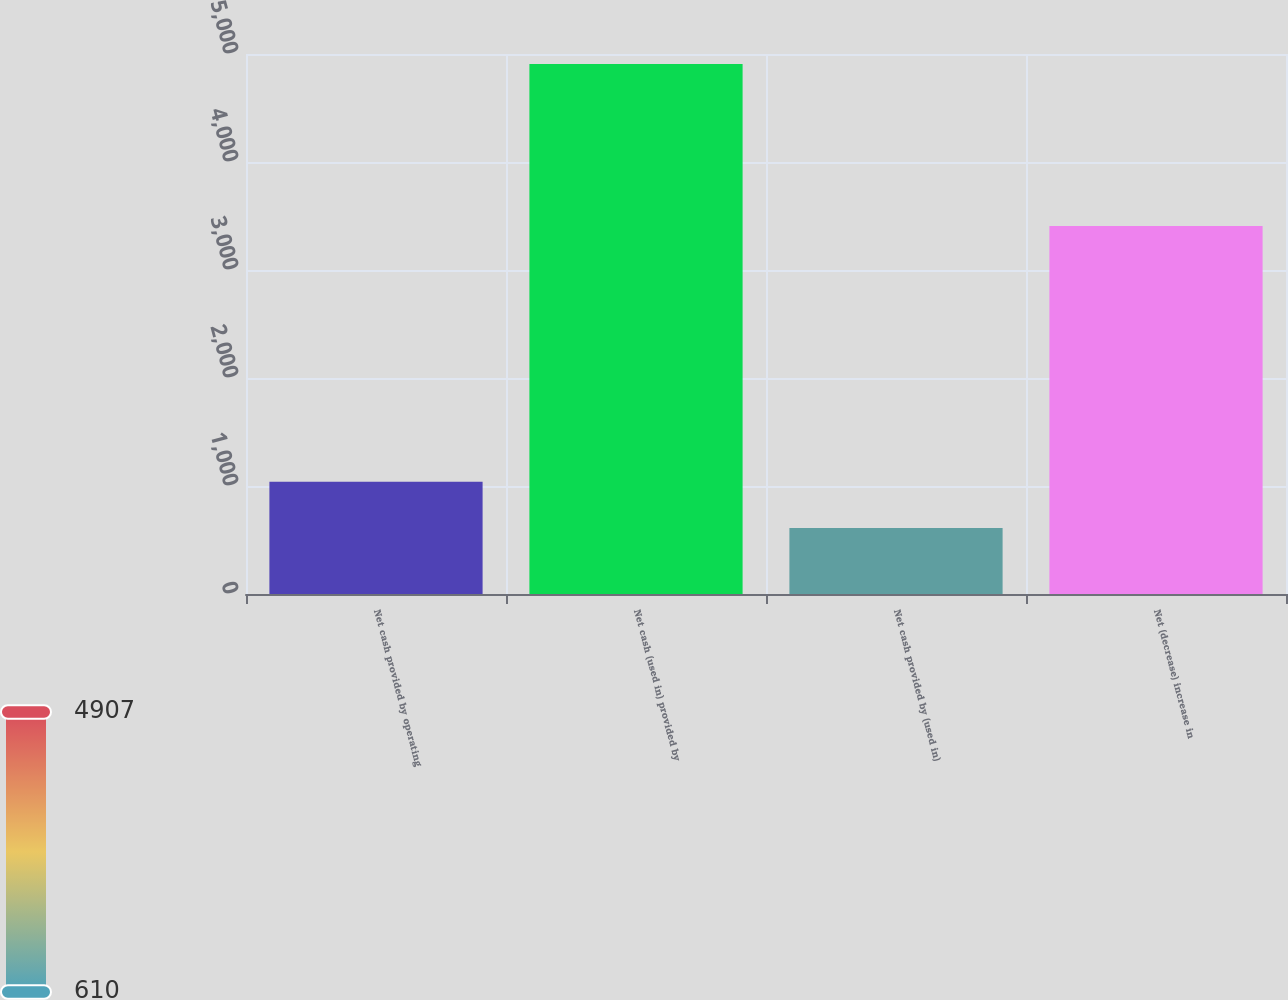<chart> <loc_0><loc_0><loc_500><loc_500><bar_chart><fcel>Net cash provided by operating<fcel>Net cash (used in) provided by<fcel>Net cash provided by (used in)<fcel>Net (decrease) increase in<nl><fcel>1039.7<fcel>4907<fcel>610<fcel>3408<nl></chart> 